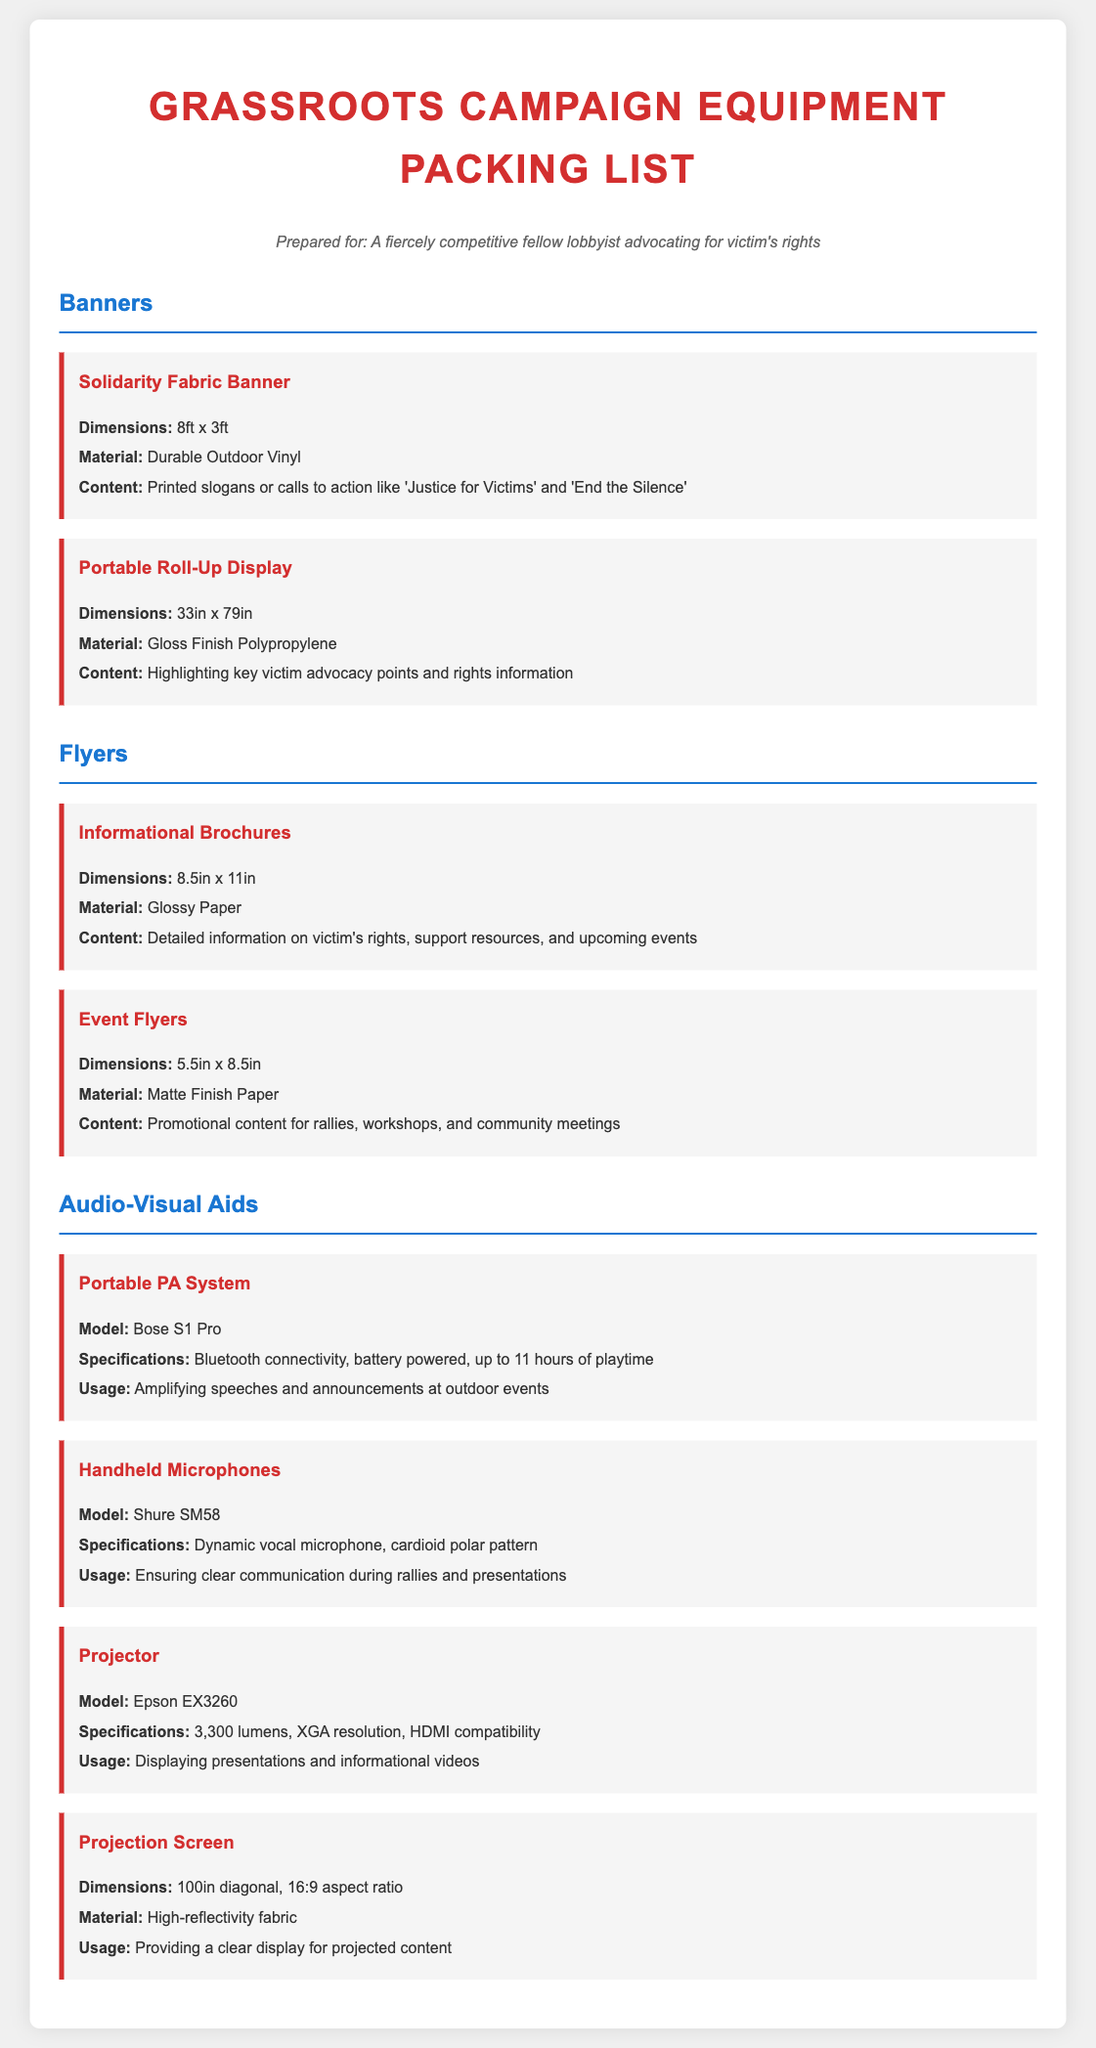What are the dimensions of the Solidarity Fabric Banner? The dimensions of the Solidarity Fabric Banner are specified in the document as 8ft x 3ft.
Answer: 8ft x 3ft What material is the Portable Roll-Up Display made of? The document states that the Portable Roll-Up Display is made of Gloss Finish Polypropylene.
Answer: Gloss Finish Polypropylene What content is included in the Informational Brochures? The Informational Brochures are described in the document as containing detailed information on victim's rights, support resources, and upcoming events.
Answer: Detailed information on victim's rights, support resources, and upcoming events How many hours of playtime does the Bose S1 Pro PA System provide? The document indicates that the Bose S1 Pro PA System offers up to 11 hours of playtime.
Answer: 11 hours What is the model of the handheld microphone listed? The document provides the model of the handheld microphone as Shure SM58.
Answer: Shure SM58 What usage is specified for the Projector? According to the document, the usage for the Projector is displaying presentations and informational videos.
Answer: Displaying presentations and informational videos What is the size of the Projection Screen? The size of the Projection Screen is stated in the document as 100in diagonal.
Answer: 100in diagonal How many types of equipment are listed under Audio-Visual Aids? There are four types of equipment listed under Audio-Visual Aids in the document.
Answer: Four types What color is the heading of the section on Banners? The document specifies that the color of the heading for the Banners section is #1976d2.
Answer: #1976d2 